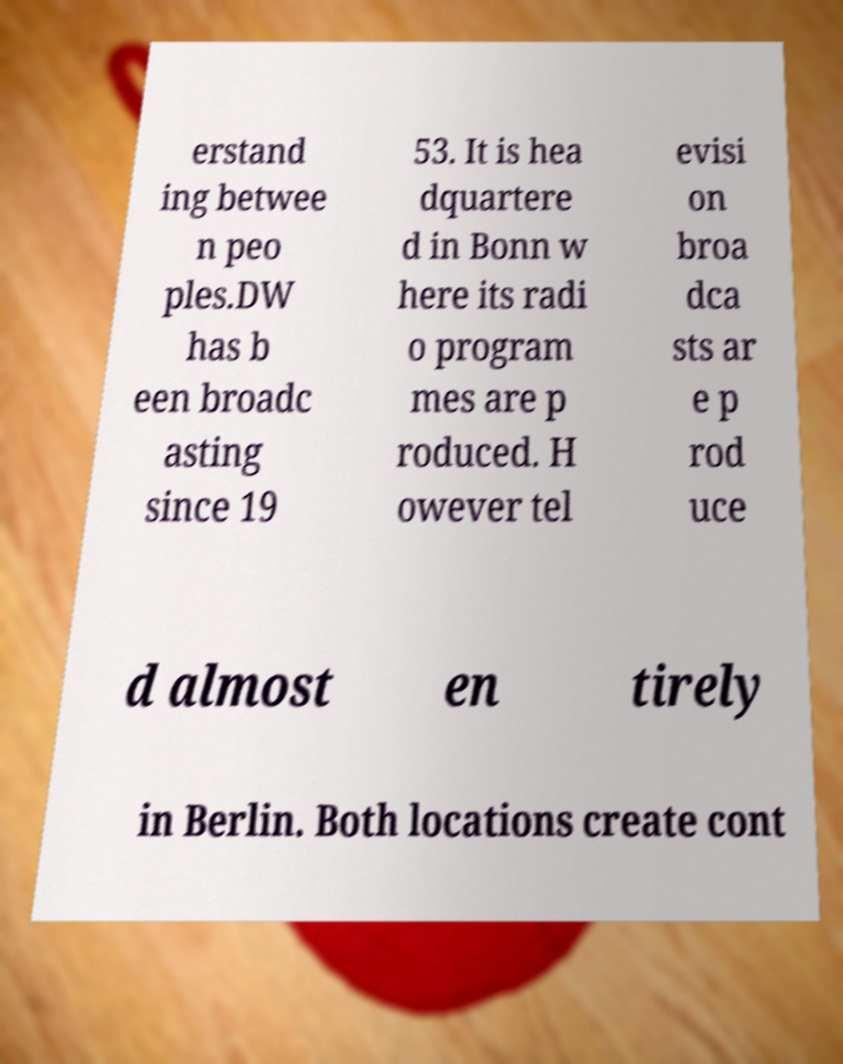I need the written content from this picture converted into text. Can you do that? erstand ing betwee n peo ples.DW has b een broadc asting since 19 53. It is hea dquartere d in Bonn w here its radi o program mes are p roduced. H owever tel evisi on broa dca sts ar e p rod uce d almost en tirely in Berlin. Both locations create cont 